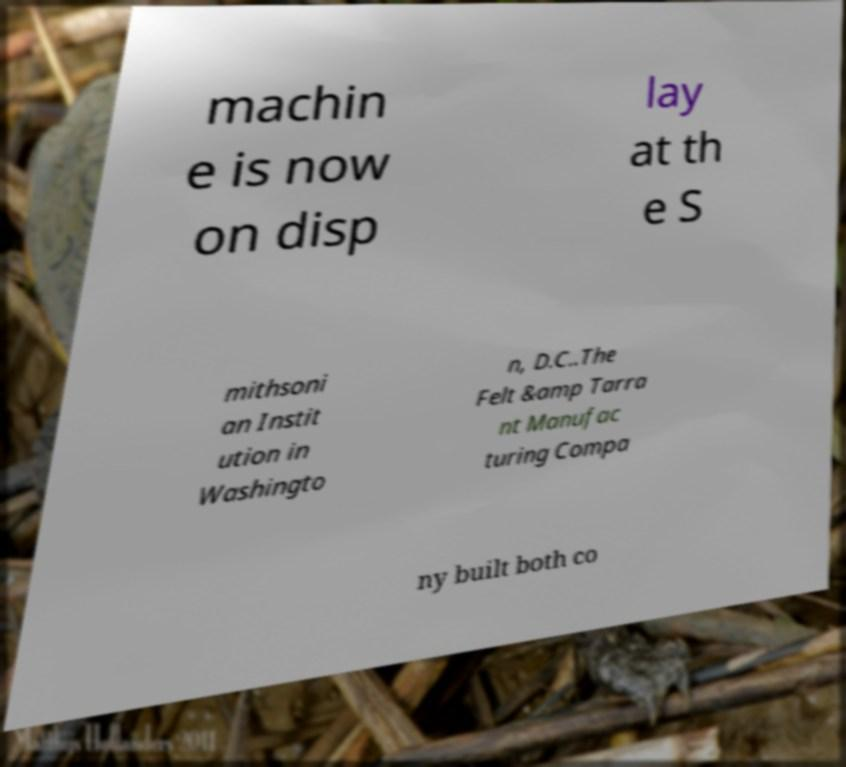I need the written content from this picture converted into text. Can you do that? machin e is now on disp lay at th e S mithsoni an Instit ution in Washingto n, D.C..The Felt &amp Tarra nt Manufac turing Compa ny built both co 